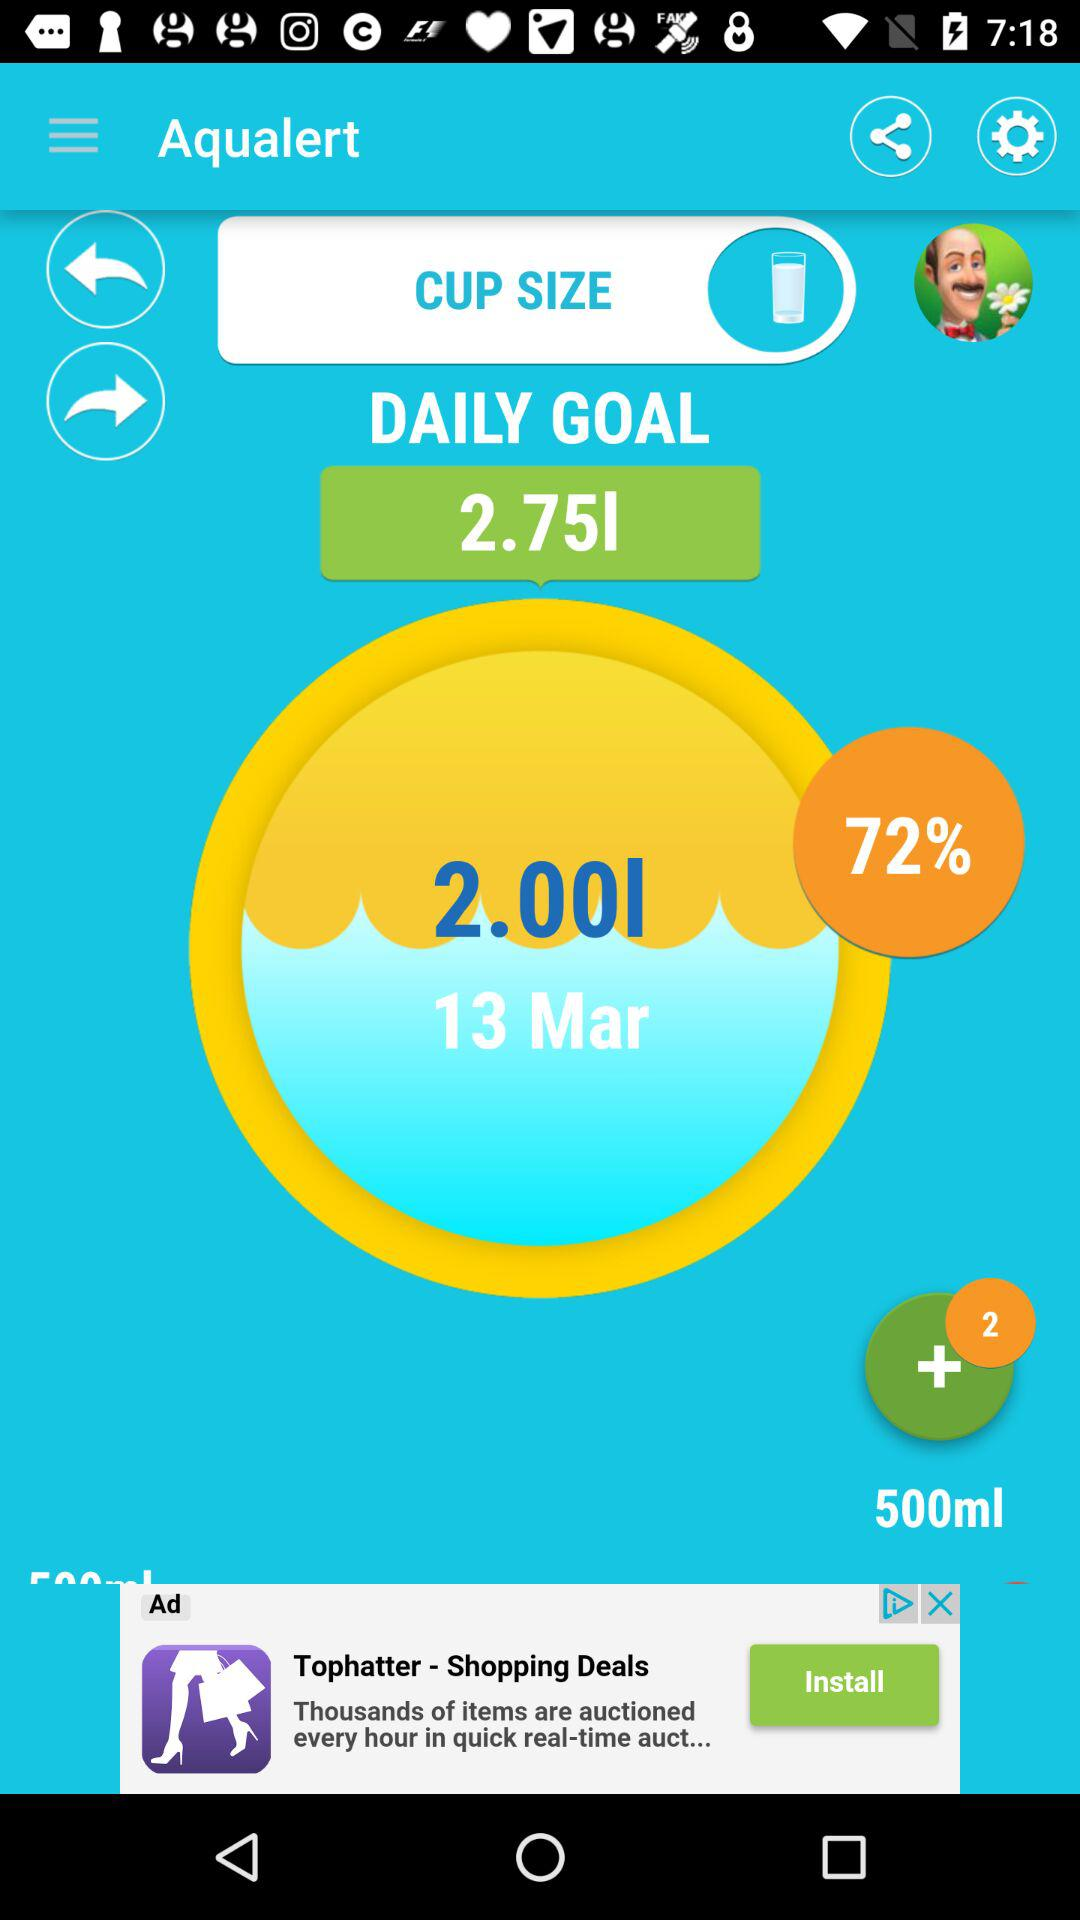What is the percentage of the goal achieved on 13 March? The percentage of the goal achieved on 13 March is 72. 